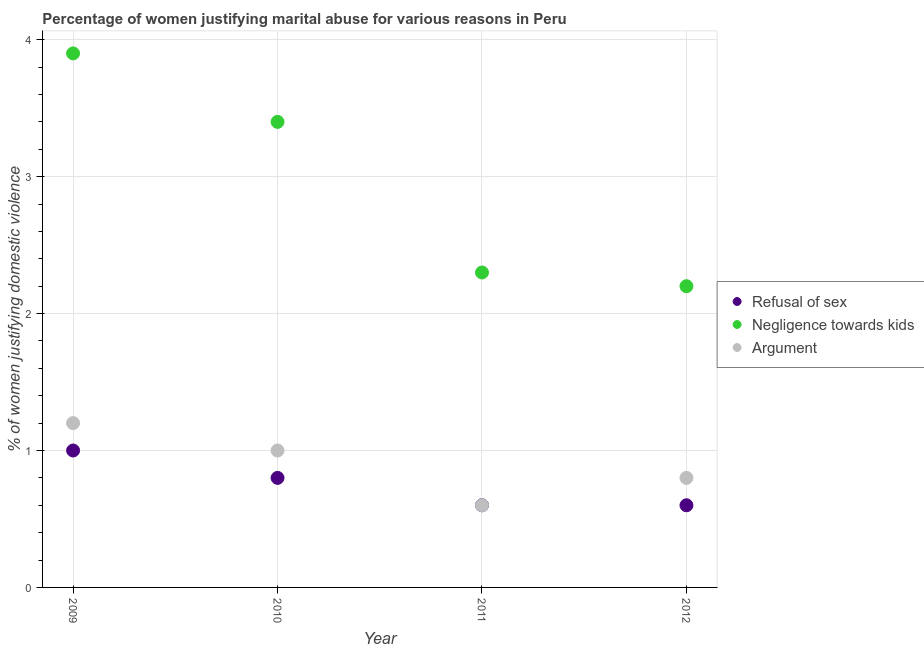What is the percentage of women justifying domestic violence due to arguments in 2012?
Provide a succinct answer. 0.8. In which year was the percentage of women justifying domestic violence due to negligence towards kids maximum?
Give a very brief answer. 2009. What is the total percentage of women justifying domestic violence due to refusal of sex in the graph?
Provide a short and direct response. 3. What is the difference between the percentage of women justifying domestic violence due to negligence towards kids in 2010 and that in 2012?
Give a very brief answer. 1.2. What is the average percentage of women justifying domestic violence due to arguments per year?
Provide a succinct answer. 0.9. What is the ratio of the percentage of women justifying domestic violence due to arguments in 2009 to that in 2010?
Your response must be concise. 1.2. Is the percentage of women justifying domestic violence due to refusal of sex in 2009 less than that in 2011?
Keep it short and to the point. No. What is the difference between the highest and the second highest percentage of women justifying domestic violence due to refusal of sex?
Keep it short and to the point. 0.2. Is the sum of the percentage of women justifying domestic violence due to negligence towards kids in 2010 and 2011 greater than the maximum percentage of women justifying domestic violence due to refusal of sex across all years?
Offer a terse response. Yes. Is it the case that in every year, the sum of the percentage of women justifying domestic violence due to refusal of sex and percentage of women justifying domestic violence due to negligence towards kids is greater than the percentage of women justifying domestic violence due to arguments?
Offer a terse response. Yes. Does the percentage of women justifying domestic violence due to arguments monotonically increase over the years?
Give a very brief answer. No. Is the percentage of women justifying domestic violence due to negligence towards kids strictly greater than the percentage of women justifying domestic violence due to refusal of sex over the years?
Ensure brevity in your answer.  Yes. How many dotlines are there?
Offer a very short reply. 3. How many years are there in the graph?
Your response must be concise. 4. What is the difference between two consecutive major ticks on the Y-axis?
Your response must be concise. 1. Does the graph contain grids?
Provide a short and direct response. Yes. How are the legend labels stacked?
Give a very brief answer. Vertical. What is the title of the graph?
Provide a short and direct response. Percentage of women justifying marital abuse for various reasons in Peru. What is the label or title of the Y-axis?
Your answer should be very brief. % of women justifying domestic violence. What is the % of women justifying domestic violence of Refusal of sex in 2009?
Offer a very short reply. 1. What is the % of women justifying domestic violence of Argument in 2009?
Give a very brief answer. 1.2. What is the % of women justifying domestic violence in Argument in 2010?
Your answer should be compact. 1. What is the % of women justifying domestic violence in Refusal of sex in 2011?
Your answer should be very brief. 0.6. What is the % of women justifying domestic violence in Argument in 2011?
Your answer should be compact. 0.6. What is the % of women justifying domestic violence of Refusal of sex in 2012?
Your answer should be very brief. 0.6. What is the % of women justifying domestic violence in Argument in 2012?
Your answer should be compact. 0.8. Across all years, what is the maximum % of women justifying domestic violence in Refusal of sex?
Your response must be concise. 1. Across all years, what is the maximum % of women justifying domestic violence of Negligence towards kids?
Your answer should be compact. 3.9. Across all years, what is the maximum % of women justifying domestic violence in Argument?
Offer a very short reply. 1.2. Across all years, what is the minimum % of women justifying domestic violence in Negligence towards kids?
Your answer should be very brief. 2.2. What is the total % of women justifying domestic violence of Refusal of sex in the graph?
Give a very brief answer. 3. What is the total % of women justifying domestic violence in Negligence towards kids in the graph?
Offer a very short reply. 11.8. What is the total % of women justifying domestic violence of Argument in the graph?
Provide a succinct answer. 3.6. What is the difference between the % of women justifying domestic violence of Refusal of sex in 2009 and that in 2010?
Ensure brevity in your answer.  0.2. What is the difference between the % of women justifying domestic violence in Argument in 2009 and that in 2010?
Provide a succinct answer. 0.2. What is the difference between the % of women justifying domestic violence in Refusal of sex in 2009 and that in 2011?
Provide a short and direct response. 0.4. What is the difference between the % of women justifying domestic violence in Argument in 2009 and that in 2011?
Ensure brevity in your answer.  0.6. What is the difference between the % of women justifying domestic violence of Refusal of sex in 2009 and that in 2012?
Your response must be concise. 0.4. What is the difference between the % of women justifying domestic violence in Negligence towards kids in 2009 and that in 2012?
Your answer should be compact. 1.7. What is the difference between the % of women justifying domestic violence of Refusal of sex in 2010 and that in 2011?
Keep it short and to the point. 0.2. What is the difference between the % of women justifying domestic violence in Negligence towards kids in 2010 and that in 2012?
Keep it short and to the point. 1.2. What is the difference between the % of women justifying domestic violence of Argument in 2010 and that in 2012?
Provide a succinct answer. 0.2. What is the difference between the % of women justifying domestic violence in Refusal of sex in 2009 and the % of women justifying domestic violence in Argument in 2010?
Keep it short and to the point. 0. What is the difference between the % of women justifying domestic violence of Refusal of sex in 2009 and the % of women justifying domestic violence of Negligence towards kids in 2011?
Keep it short and to the point. -1.3. What is the difference between the % of women justifying domestic violence of Refusal of sex in 2009 and the % of women justifying domestic violence of Negligence towards kids in 2012?
Your answer should be very brief. -1.2. What is the difference between the % of women justifying domestic violence of Refusal of sex in 2009 and the % of women justifying domestic violence of Argument in 2012?
Offer a very short reply. 0.2. What is the difference between the % of women justifying domestic violence in Negligence towards kids in 2010 and the % of women justifying domestic violence in Argument in 2011?
Keep it short and to the point. 2.8. What is the difference between the % of women justifying domestic violence of Refusal of sex in 2010 and the % of women justifying domestic violence of Negligence towards kids in 2012?
Provide a succinct answer. -1.4. What is the difference between the % of women justifying domestic violence of Refusal of sex in 2010 and the % of women justifying domestic violence of Argument in 2012?
Provide a succinct answer. 0. What is the difference between the % of women justifying domestic violence in Refusal of sex in 2011 and the % of women justifying domestic violence in Negligence towards kids in 2012?
Your answer should be compact. -1.6. What is the difference between the % of women justifying domestic violence in Refusal of sex in 2011 and the % of women justifying domestic violence in Argument in 2012?
Your answer should be very brief. -0.2. What is the average % of women justifying domestic violence of Negligence towards kids per year?
Your response must be concise. 2.95. In the year 2009, what is the difference between the % of women justifying domestic violence in Refusal of sex and % of women justifying domestic violence in Negligence towards kids?
Offer a very short reply. -2.9. In the year 2009, what is the difference between the % of women justifying domestic violence of Negligence towards kids and % of women justifying domestic violence of Argument?
Ensure brevity in your answer.  2.7. In the year 2010, what is the difference between the % of women justifying domestic violence in Negligence towards kids and % of women justifying domestic violence in Argument?
Provide a succinct answer. 2.4. In the year 2011, what is the difference between the % of women justifying domestic violence of Refusal of sex and % of women justifying domestic violence of Argument?
Your answer should be compact. 0. In the year 2012, what is the difference between the % of women justifying domestic violence in Refusal of sex and % of women justifying domestic violence in Negligence towards kids?
Give a very brief answer. -1.6. In the year 2012, what is the difference between the % of women justifying domestic violence of Negligence towards kids and % of women justifying domestic violence of Argument?
Make the answer very short. 1.4. What is the ratio of the % of women justifying domestic violence of Negligence towards kids in 2009 to that in 2010?
Ensure brevity in your answer.  1.15. What is the ratio of the % of women justifying domestic violence in Refusal of sex in 2009 to that in 2011?
Give a very brief answer. 1.67. What is the ratio of the % of women justifying domestic violence in Negligence towards kids in 2009 to that in 2011?
Offer a terse response. 1.7. What is the ratio of the % of women justifying domestic violence of Argument in 2009 to that in 2011?
Your answer should be very brief. 2. What is the ratio of the % of women justifying domestic violence of Refusal of sex in 2009 to that in 2012?
Your answer should be compact. 1.67. What is the ratio of the % of women justifying domestic violence in Negligence towards kids in 2009 to that in 2012?
Offer a terse response. 1.77. What is the ratio of the % of women justifying domestic violence of Argument in 2009 to that in 2012?
Keep it short and to the point. 1.5. What is the ratio of the % of women justifying domestic violence in Negligence towards kids in 2010 to that in 2011?
Make the answer very short. 1.48. What is the ratio of the % of women justifying domestic violence in Negligence towards kids in 2010 to that in 2012?
Your answer should be very brief. 1.55. What is the ratio of the % of women justifying domestic violence in Argument in 2010 to that in 2012?
Ensure brevity in your answer.  1.25. What is the ratio of the % of women justifying domestic violence of Refusal of sex in 2011 to that in 2012?
Provide a short and direct response. 1. What is the ratio of the % of women justifying domestic violence of Negligence towards kids in 2011 to that in 2012?
Your response must be concise. 1.05. What is the ratio of the % of women justifying domestic violence in Argument in 2011 to that in 2012?
Offer a terse response. 0.75. What is the difference between the highest and the lowest % of women justifying domestic violence in Refusal of sex?
Give a very brief answer. 0.4. What is the difference between the highest and the lowest % of women justifying domestic violence in Negligence towards kids?
Your answer should be very brief. 1.7. 